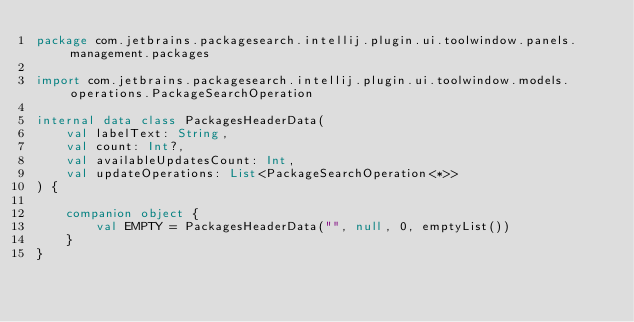<code> <loc_0><loc_0><loc_500><loc_500><_Kotlin_>package com.jetbrains.packagesearch.intellij.plugin.ui.toolwindow.panels.management.packages

import com.jetbrains.packagesearch.intellij.plugin.ui.toolwindow.models.operations.PackageSearchOperation

internal data class PackagesHeaderData(
    val labelText: String,
    val count: Int?,
    val availableUpdatesCount: Int,
    val updateOperations: List<PackageSearchOperation<*>>
) {

    companion object {
        val EMPTY = PackagesHeaderData("", null, 0, emptyList())
    }
}
</code> 